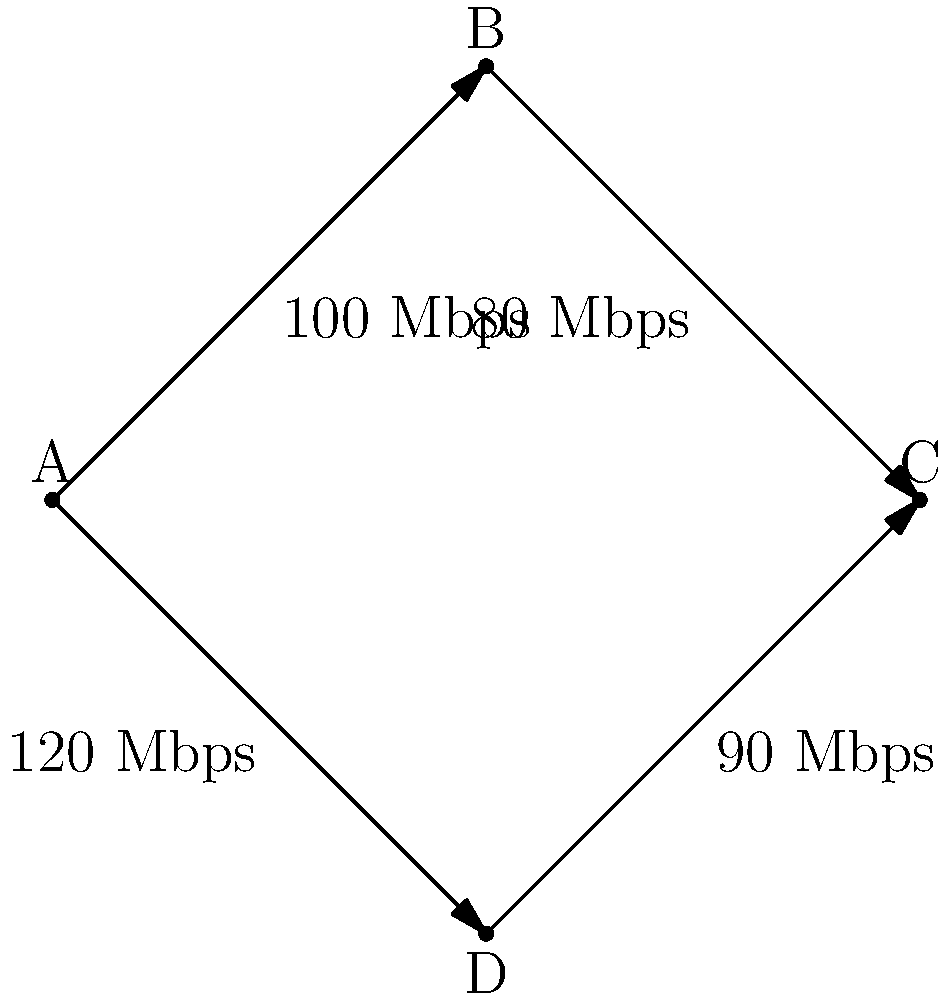As a business owner who understands the importance of efficient data transfer, you need to determine the maximum network throughput from node A to node C in the given network diagram. What is the maximum throughput in Mbps? To find the maximum network throughput from node A to node C, we need to identify all possible paths and their respective bottlenecks:

1. Path 1: A → B → C
   Bottleneck = min(100 Mbps, 80 Mbps) = 80 Mbps

2. Path 2: A → D → C
   Bottleneck = min(120 Mbps, 90 Mbps) = 90 Mbps

The maximum throughput is the sum of the bottlenecks of all independent paths:

Maximum Throughput = Path 1 + Path 2
                   = 80 Mbps + 90 Mbps
                   = 170 Mbps

This approach is based on the max-flow min-cut theorem, which states that the maximum flow in a network is equal to the minimum cut capacity.
Answer: 170 Mbps 